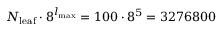Convert formula to latex. <formula><loc_0><loc_0><loc_500><loc_500>N _ { l e a f } \cdot 8 ^ { l _ { \max } } = 1 0 0 \cdot 8 ^ { 5 } = 3 2 7 6 8 0 0</formula> 